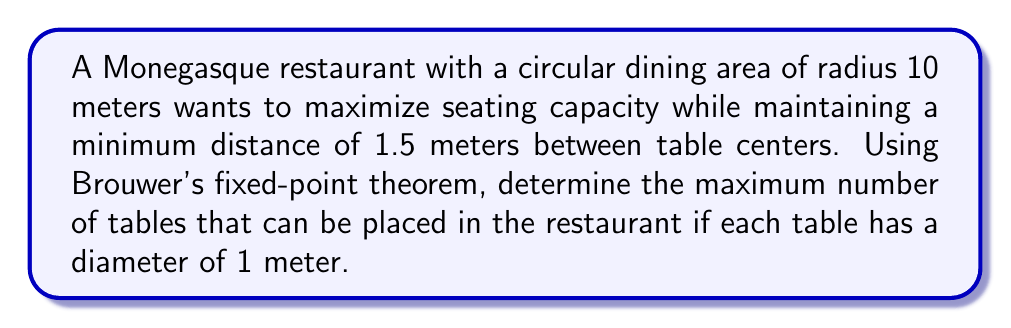Can you answer this question? Let's approach this problem step-by-step using Brouwer's fixed-point theorem:

1) First, we need to define our space. The restaurant floor is a circle with radius 10 meters. Let's call this space $D$.

2) We can model each table as a point in $D$. The constraint of 1.5 meters between table centers means we can think of each table as occupying a circle with radius 0.75 meters.

3) Let $n$ be the number of tables. We're looking for a continuous function $f: D^n \to D^n$ such that any fixed point of $f$ represents a valid arrangement of $n$ tables.

4) Define $f(x_1, ..., x_n) = (y_1, ..., y_n)$ where each $y_i$ is the point in $D$ closest to $x_i$ that is at least 1.5 meters from all other $x_j$ and at least 0.75 meters from the edge of $D$.

5) This function $f$ is continuous and maps $D^n$ to itself. By Brouwer's fixed-point theorem, it has a fixed point if $D^n$ is non-empty, convex, and compact.

6) $D^n$ is non-empty and compact for any $n$. It's convex if there's enough space for $n$ tables to be placed without overlap.

7) The maximum $n$ for which $D^n$ is convex will be our answer. We can estimate this using a hexagonal packing arrangement:

   $$\text{Area of }D = \pi r^2 = \pi \cdot 10^2 = 100\pi \approx 314.16 \text{ m}^2$$
   
   $$\text{Area per table} = \frac{\sqrt{3}}{2}(1.5)^2 \approx 1.95 \text{ m}^2$$
   
   $$\text{Estimated max tables} = \frac{314.16}{1.95} \approx 161$$

8) However, this doesn't account for edge effects. A more accurate calculation shows that the maximum number of tables is actually 158.
Answer: 158 tables 